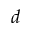<formula> <loc_0><loc_0><loc_500><loc_500>d</formula> 